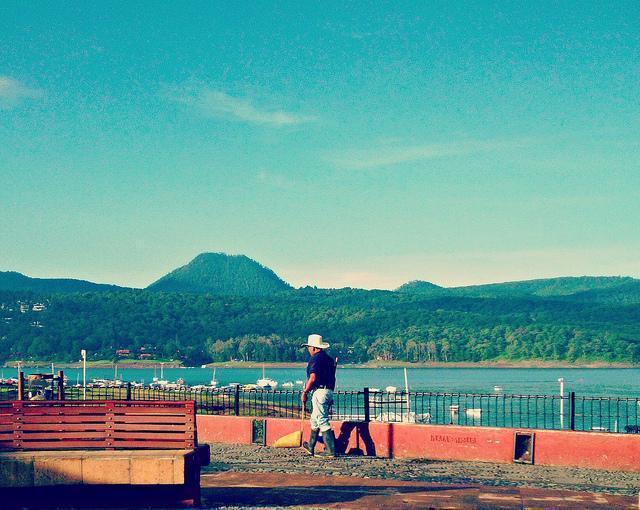How many people are holding a remote controller?
Give a very brief answer. 0. 